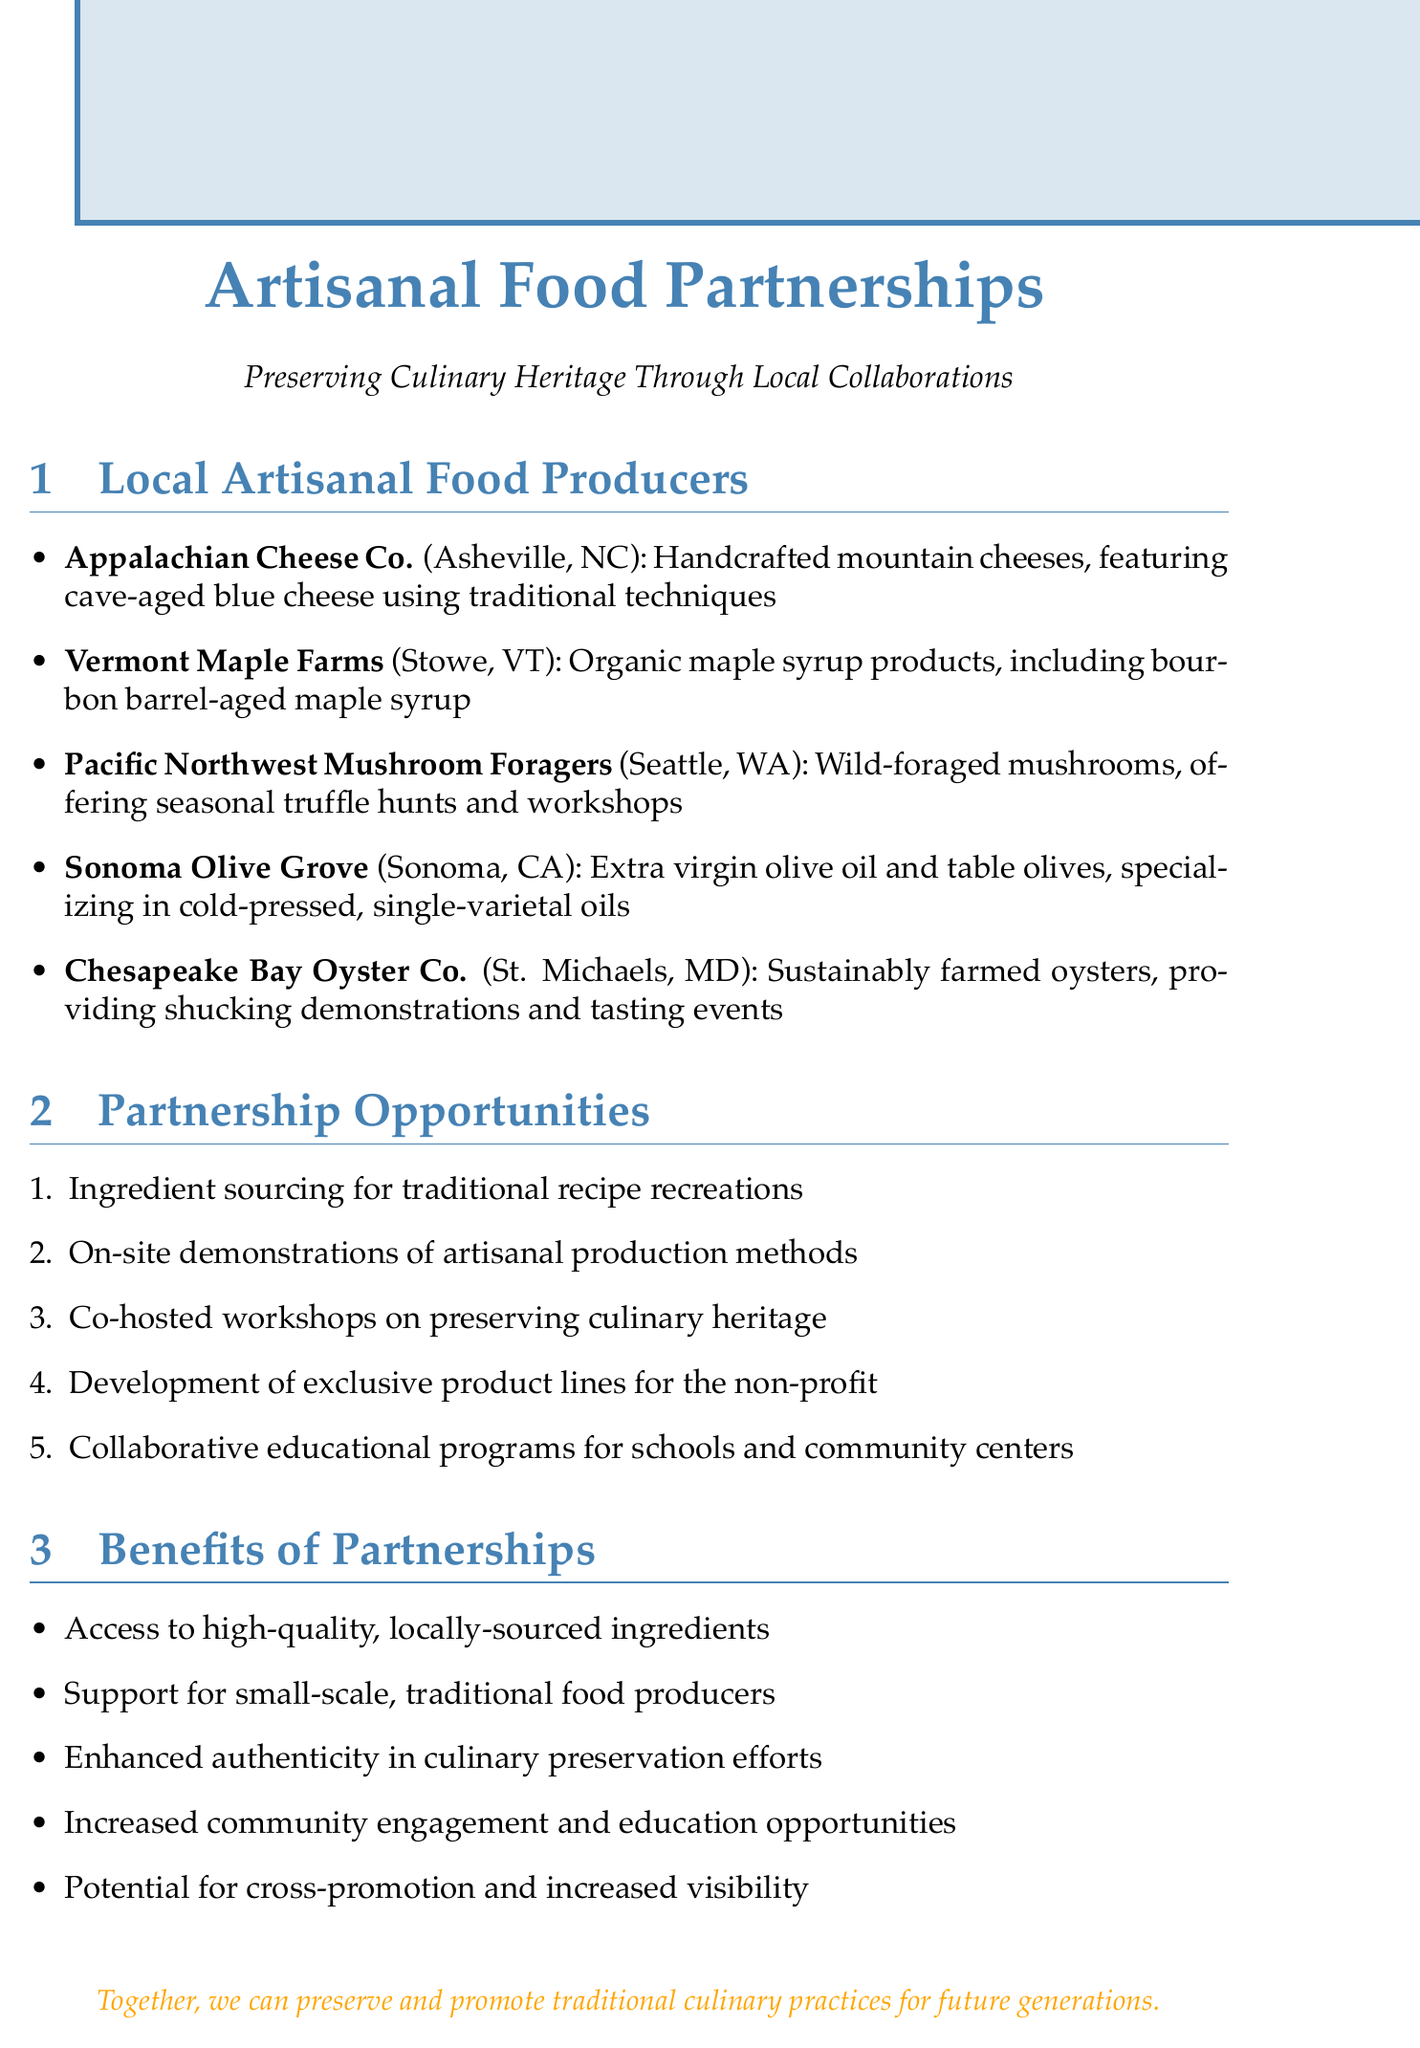What is the specialty of Appalachian Cheese Co.? The specialty mentioned for Appalachian Cheese Co. is handcrafted mountain cheeses.
Answer: Handcrafted mountain cheeses Where is Vermont Maple Farms located? The location of Vermont Maple Farms is specified as Stowe, Vermont.
Answer: Stowe, Vermont What unique offering does Chesapeake Bay Oyster Co. provide? The unique offering provided by Chesapeake Bay Oyster Co. is oyster shucking demonstrations and tasting events.
Answer: Oyster shucking demonstrations and tasting events What is one partnership opportunity listed in the document? The document lists multiple partnership opportunities, one of which is ingredient sourcing for traditional recipe recreations.
Answer: Ingredient sourcing for traditional recipe recreations How many local artisanal food producers are mentioned? The document states a total of five local artisanal food producers.
Answer: Five What is a benefit of the partnerships highlighted in the document? One benefit listed in the document is access to high-quality, locally-sourced ingredients.
Answer: Access to high-quality, locally-sourced ingredients What type of workshops can be co-hosted according to the document? The document suggests co-hosted workshops on preserving culinary heritage.
Answer: Preserving culinary heritage What is the overarching goal of the collaborations mentioned in the notes? The overarching goal is preserving and promoting traditional culinary practices.
Answer: Preserving and promoting traditional culinary practices 